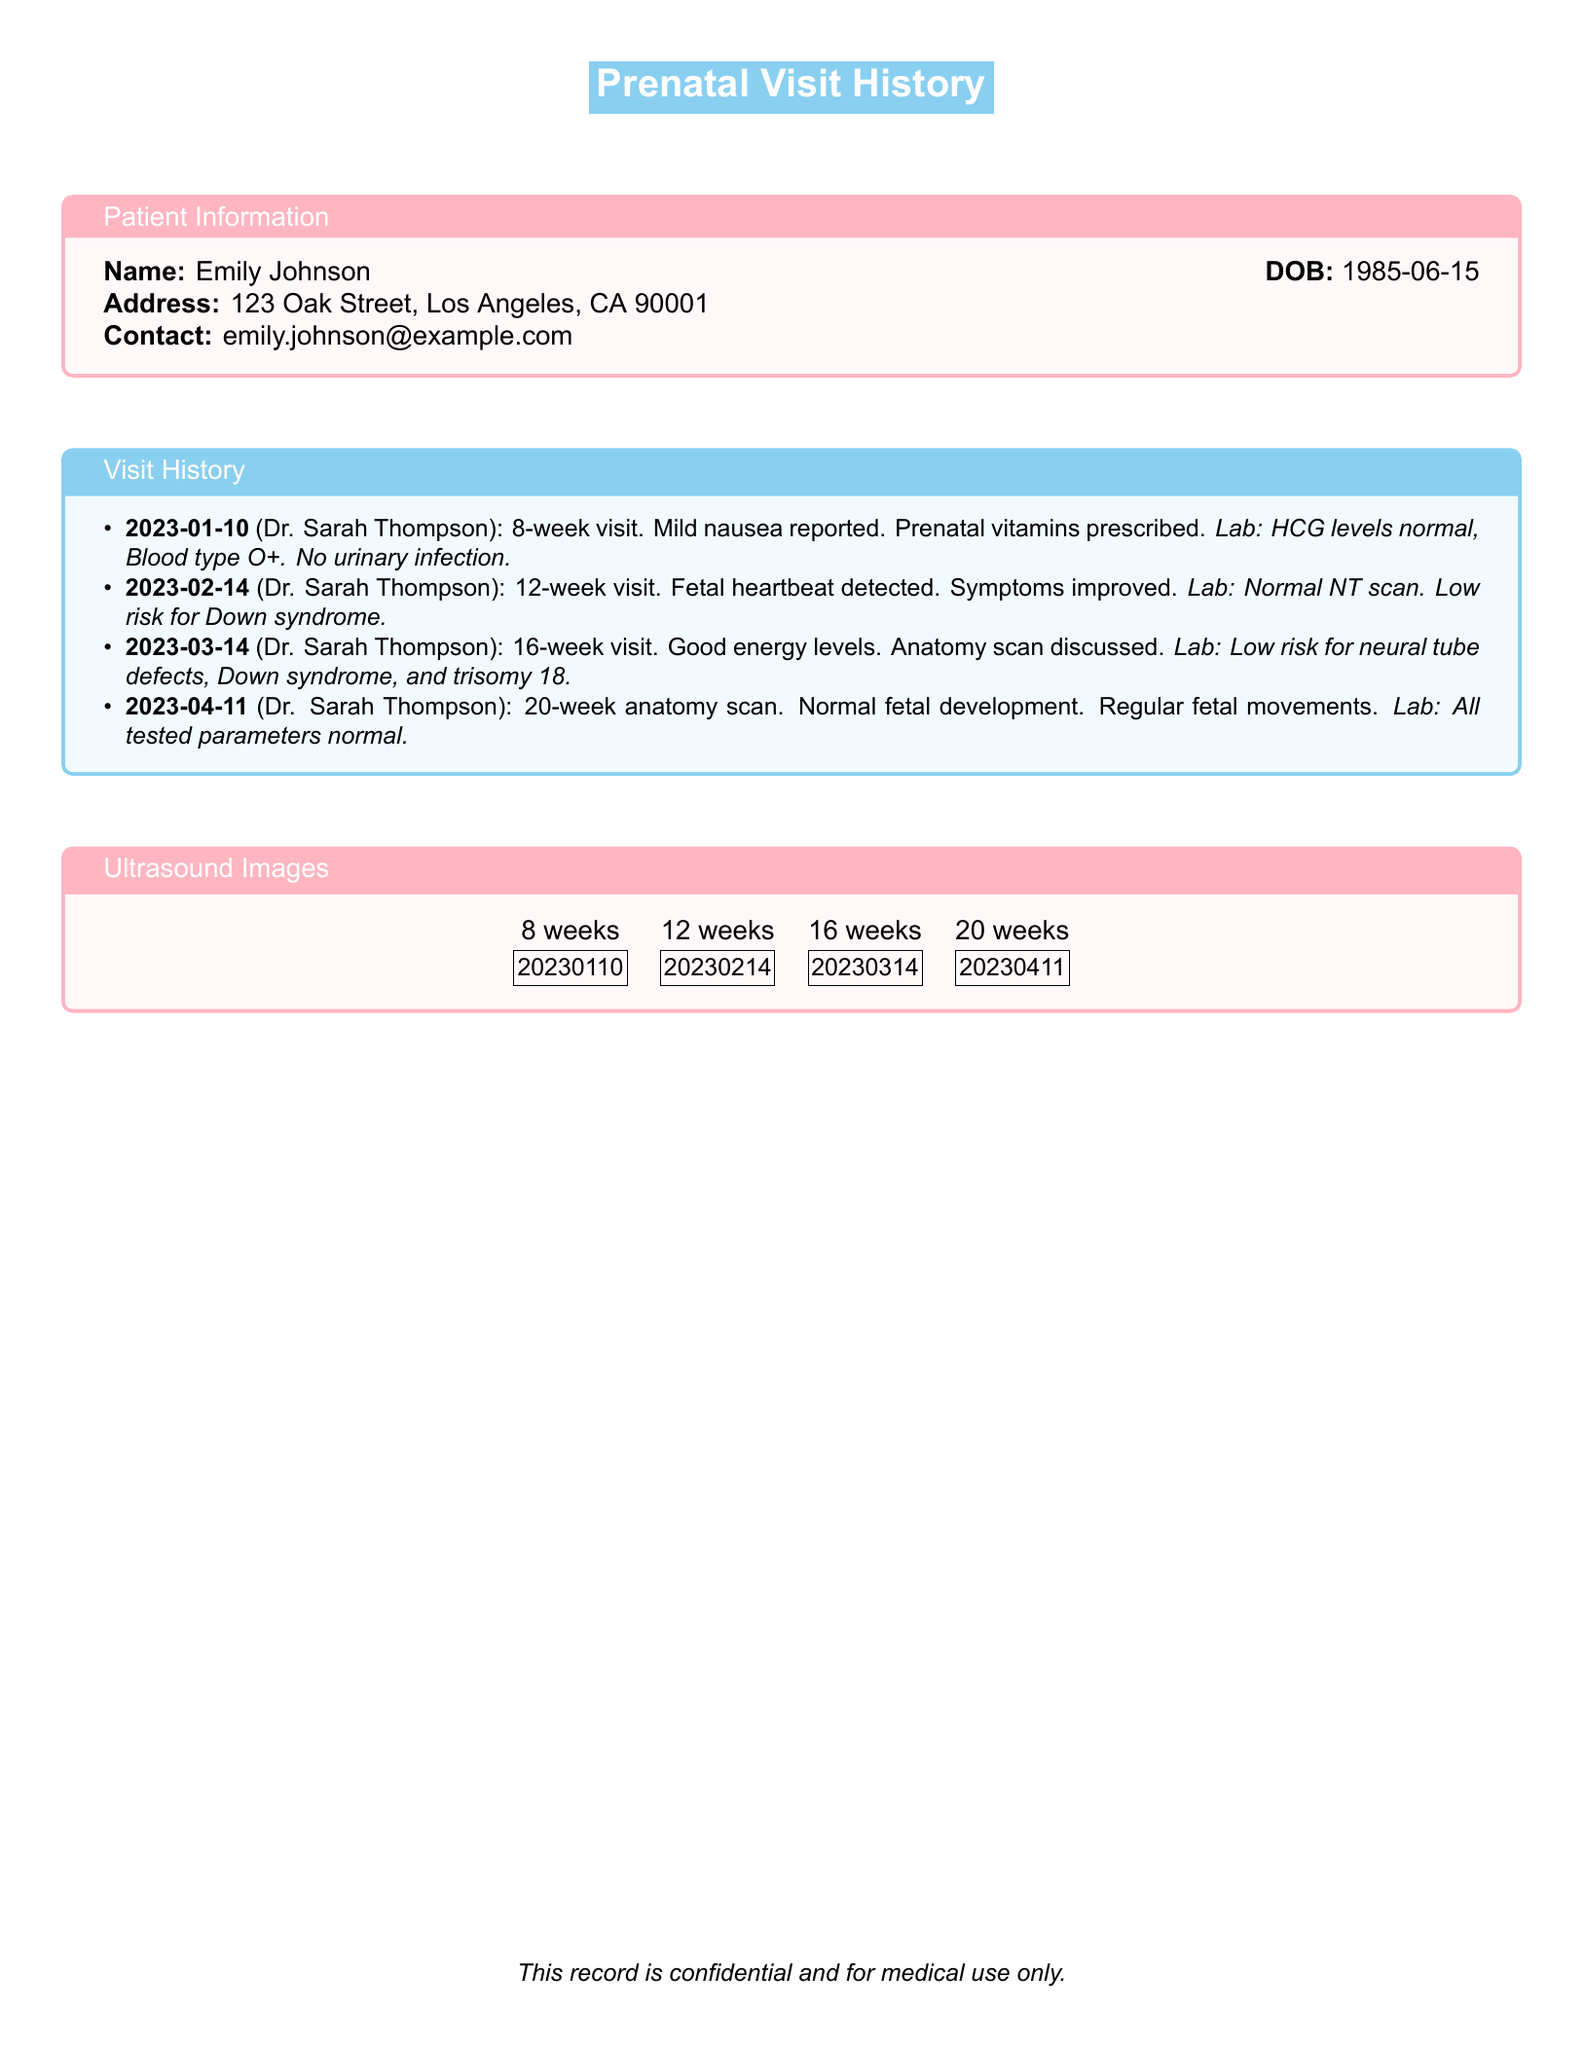What is the name of the patient? The patient's name is specified at the top of the document.
Answer: Emily Johnson What is the date of the first prenatal visit? The date of the first visit is noted in the visit history section.
Answer: 2023-01-10 Who is the healthcare provider for the visits? The healthcare provider is consistently mentioned in the visit history box.
Answer: Dr. Sarah Thompson What was reported at the 12-week visit? The notes from the 12-week visit summarize key findings and symptoms.
Answer: Fetal heartbeat detected How many weeks pregnant was the patient during the 20-week visit? The visit at 20 weeks is clearly identified in the visit history section.
Answer: 20 weeks What were the results for the neural tube defects test? The results for this test are part of the lab results for the 16-week visit.
Answer: Low risk What type of test was conducted at the 20-week visit? The type of scan highlighted during the 20-week visit can be traced in the document.
Answer: Anatomy scan How many total visits are documented? The number of visits is easily counted from the visit history section.
Answer: 4 